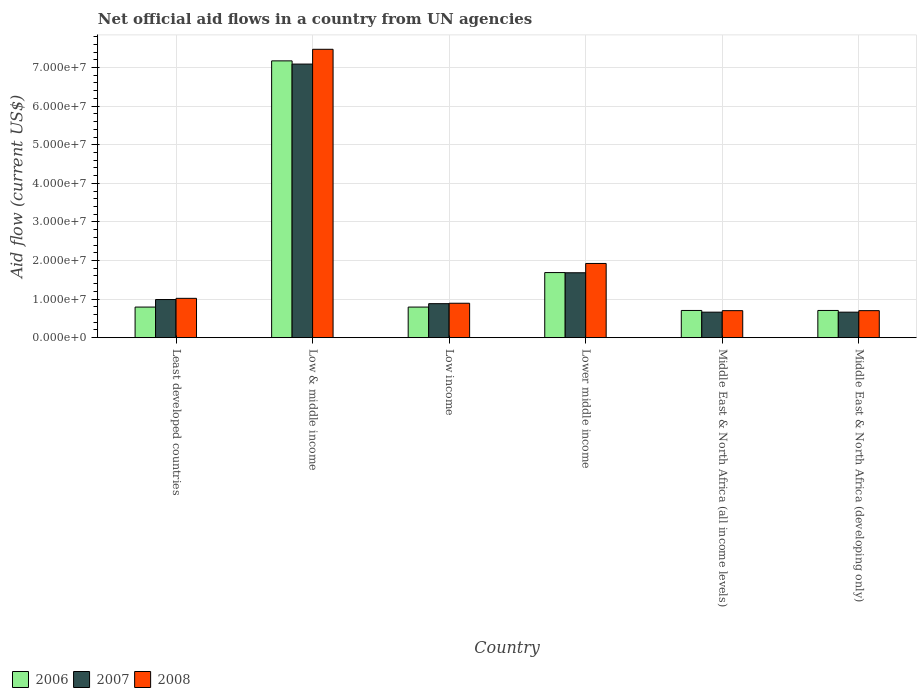Are the number of bars per tick equal to the number of legend labels?
Ensure brevity in your answer.  Yes. How many bars are there on the 6th tick from the right?
Your answer should be compact. 3. What is the label of the 5th group of bars from the left?
Your response must be concise. Middle East & North Africa (all income levels). What is the net official aid flow in 2006 in Low & middle income?
Ensure brevity in your answer.  7.17e+07. Across all countries, what is the maximum net official aid flow in 2008?
Your answer should be compact. 7.47e+07. Across all countries, what is the minimum net official aid flow in 2007?
Your answer should be compact. 6.61e+06. In which country was the net official aid flow in 2008 minimum?
Make the answer very short. Middle East & North Africa (all income levels). What is the total net official aid flow in 2008 in the graph?
Provide a succinct answer. 1.27e+08. What is the difference between the net official aid flow in 2007 in Low income and that in Middle East & North Africa (developing only)?
Provide a succinct answer. 2.20e+06. What is the difference between the net official aid flow in 2008 in Low income and the net official aid flow in 2006 in Low & middle income?
Your answer should be compact. -6.28e+07. What is the average net official aid flow in 2006 per country?
Your response must be concise. 1.98e+07. What is the difference between the net official aid flow of/in 2008 and net official aid flow of/in 2006 in Low income?
Offer a very short reply. 9.90e+05. In how many countries, is the net official aid flow in 2006 greater than 40000000 US$?
Give a very brief answer. 1. What is the ratio of the net official aid flow in 2007 in Low income to that in Middle East & North Africa (all income levels)?
Give a very brief answer. 1.33. Is the net official aid flow in 2006 in Least developed countries less than that in Middle East & North Africa (developing only)?
Provide a short and direct response. No. Is the difference between the net official aid flow in 2008 in Low & middle income and Lower middle income greater than the difference between the net official aid flow in 2006 in Low & middle income and Lower middle income?
Offer a very short reply. Yes. What is the difference between the highest and the second highest net official aid flow in 2008?
Your answer should be very brief. 5.55e+07. What is the difference between the highest and the lowest net official aid flow in 2008?
Ensure brevity in your answer.  6.77e+07. Is the sum of the net official aid flow in 2008 in Least developed countries and Middle East & North Africa (developing only) greater than the maximum net official aid flow in 2006 across all countries?
Ensure brevity in your answer.  No. How many countries are there in the graph?
Make the answer very short. 6. Does the graph contain any zero values?
Provide a short and direct response. No. Does the graph contain grids?
Your answer should be compact. Yes. Where does the legend appear in the graph?
Offer a very short reply. Bottom left. What is the title of the graph?
Provide a succinct answer. Net official aid flows in a country from UN agencies. What is the label or title of the X-axis?
Make the answer very short. Country. What is the Aid flow (current US$) in 2006 in Least developed countries?
Give a very brief answer. 7.93e+06. What is the Aid flow (current US$) of 2007 in Least developed countries?
Keep it short and to the point. 9.88e+06. What is the Aid flow (current US$) in 2008 in Least developed countries?
Ensure brevity in your answer.  1.02e+07. What is the Aid flow (current US$) in 2006 in Low & middle income?
Make the answer very short. 7.17e+07. What is the Aid flow (current US$) of 2007 in Low & middle income?
Your answer should be compact. 7.09e+07. What is the Aid flow (current US$) in 2008 in Low & middle income?
Your response must be concise. 7.47e+07. What is the Aid flow (current US$) of 2006 in Low income?
Offer a very short reply. 7.93e+06. What is the Aid flow (current US$) of 2007 in Low income?
Your response must be concise. 8.81e+06. What is the Aid flow (current US$) in 2008 in Low income?
Give a very brief answer. 8.92e+06. What is the Aid flow (current US$) in 2006 in Lower middle income?
Ensure brevity in your answer.  1.69e+07. What is the Aid flow (current US$) in 2007 in Lower middle income?
Your answer should be very brief. 1.68e+07. What is the Aid flow (current US$) of 2008 in Lower middle income?
Your response must be concise. 1.92e+07. What is the Aid flow (current US$) of 2006 in Middle East & North Africa (all income levels)?
Offer a very short reply. 7.05e+06. What is the Aid flow (current US$) in 2007 in Middle East & North Africa (all income levels)?
Ensure brevity in your answer.  6.61e+06. What is the Aid flow (current US$) of 2008 in Middle East & North Africa (all income levels)?
Give a very brief answer. 7.00e+06. What is the Aid flow (current US$) in 2006 in Middle East & North Africa (developing only)?
Make the answer very short. 7.05e+06. What is the Aid flow (current US$) of 2007 in Middle East & North Africa (developing only)?
Your answer should be very brief. 6.61e+06. What is the Aid flow (current US$) in 2008 in Middle East & North Africa (developing only)?
Ensure brevity in your answer.  7.00e+06. Across all countries, what is the maximum Aid flow (current US$) of 2006?
Make the answer very short. 7.17e+07. Across all countries, what is the maximum Aid flow (current US$) in 2007?
Your answer should be compact. 7.09e+07. Across all countries, what is the maximum Aid flow (current US$) in 2008?
Your response must be concise. 7.47e+07. Across all countries, what is the minimum Aid flow (current US$) of 2006?
Your answer should be compact. 7.05e+06. Across all countries, what is the minimum Aid flow (current US$) of 2007?
Make the answer very short. 6.61e+06. Across all countries, what is the minimum Aid flow (current US$) of 2008?
Your answer should be compact. 7.00e+06. What is the total Aid flow (current US$) of 2006 in the graph?
Ensure brevity in your answer.  1.19e+08. What is the total Aid flow (current US$) of 2007 in the graph?
Offer a terse response. 1.20e+08. What is the total Aid flow (current US$) in 2008 in the graph?
Offer a terse response. 1.27e+08. What is the difference between the Aid flow (current US$) of 2006 in Least developed countries and that in Low & middle income?
Offer a terse response. -6.38e+07. What is the difference between the Aid flow (current US$) of 2007 in Least developed countries and that in Low & middle income?
Provide a succinct answer. -6.10e+07. What is the difference between the Aid flow (current US$) of 2008 in Least developed countries and that in Low & middle income?
Keep it short and to the point. -6.45e+07. What is the difference between the Aid flow (current US$) in 2007 in Least developed countries and that in Low income?
Keep it short and to the point. 1.07e+06. What is the difference between the Aid flow (current US$) in 2008 in Least developed countries and that in Low income?
Your response must be concise. 1.27e+06. What is the difference between the Aid flow (current US$) in 2006 in Least developed countries and that in Lower middle income?
Keep it short and to the point. -8.94e+06. What is the difference between the Aid flow (current US$) of 2007 in Least developed countries and that in Lower middle income?
Offer a terse response. -6.94e+06. What is the difference between the Aid flow (current US$) in 2008 in Least developed countries and that in Lower middle income?
Your response must be concise. -9.04e+06. What is the difference between the Aid flow (current US$) in 2006 in Least developed countries and that in Middle East & North Africa (all income levels)?
Give a very brief answer. 8.80e+05. What is the difference between the Aid flow (current US$) of 2007 in Least developed countries and that in Middle East & North Africa (all income levels)?
Provide a short and direct response. 3.27e+06. What is the difference between the Aid flow (current US$) in 2008 in Least developed countries and that in Middle East & North Africa (all income levels)?
Keep it short and to the point. 3.19e+06. What is the difference between the Aid flow (current US$) in 2006 in Least developed countries and that in Middle East & North Africa (developing only)?
Offer a terse response. 8.80e+05. What is the difference between the Aid flow (current US$) of 2007 in Least developed countries and that in Middle East & North Africa (developing only)?
Your answer should be very brief. 3.27e+06. What is the difference between the Aid flow (current US$) in 2008 in Least developed countries and that in Middle East & North Africa (developing only)?
Provide a succinct answer. 3.19e+06. What is the difference between the Aid flow (current US$) in 2006 in Low & middle income and that in Low income?
Your answer should be very brief. 6.38e+07. What is the difference between the Aid flow (current US$) of 2007 in Low & middle income and that in Low income?
Give a very brief answer. 6.21e+07. What is the difference between the Aid flow (current US$) of 2008 in Low & middle income and that in Low income?
Keep it short and to the point. 6.58e+07. What is the difference between the Aid flow (current US$) in 2006 in Low & middle income and that in Lower middle income?
Provide a short and direct response. 5.49e+07. What is the difference between the Aid flow (current US$) in 2007 in Low & middle income and that in Lower middle income?
Make the answer very short. 5.41e+07. What is the difference between the Aid flow (current US$) in 2008 in Low & middle income and that in Lower middle income?
Make the answer very short. 5.55e+07. What is the difference between the Aid flow (current US$) of 2006 in Low & middle income and that in Middle East & North Africa (all income levels)?
Provide a succinct answer. 6.47e+07. What is the difference between the Aid flow (current US$) of 2007 in Low & middle income and that in Middle East & North Africa (all income levels)?
Make the answer very short. 6.43e+07. What is the difference between the Aid flow (current US$) in 2008 in Low & middle income and that in Middle East & North Africa (all income levels)?
Your response must be concise. 6.77e+07. What is the difference between the Aid flow (current US$) in 2006 in Low & middle income and that in Middle East & North Africa (developing only)?
Your response must be concise. 6.47e+07. What is the difference between the Aid flow (current US$) in 2007 in Low & middle income and that in Middle East & North Africa (developing only)?
Offer a terse response. 6.43e+07. What is the difference between the Aid flow (current US$) of 2008 in Low & middle income and that in Middle East & North Africa (developing only)?
Your response must be concise. 6.77e+07. What is the difference between the Aid flow (current US$) in 2006 in Low income and that in Lower middle income?
Your answer should be compact. -8.94e+06. What is the difference between the Aid flow (current US$) of 2007 in Low income and that in Lower middle income?
Offer a terse response. -8.01e+06. What is the difference between the Aid flow (current US$) of 2008 in Low income and that in Lower middle income?
Your response must be concise. -1.03e+07. What is the difference between the Aid flow (current US$) of 2006 in Low income and that in Middle East & North Africa (all income levels)?
Keep it short and to the point. 8.80e+05. What is the difference between the Aid flow (current US$) of 2007 in Low income and that in Middle East & North Africa (all income levels)?
Make the answer very short. 2.20e+06. What is the difference between the Aid flow (current US$) in 2008 in Low income and that in Middle East & North Africa (all income levels)?
Offer a terse response. 1.92e+06. What is the difference between the Aid flow (current US$) of 2006 in Low income and that in Middle East & North Africa (developing only)?
Give a very brief answer. 8.80e+05. What is the difference between the Aid flow (current US$) of 2007 in Low income and that in Middle East & North Africa (developing only)?
Provide a succinct answer. 2.20e+06. What is the difference between the Aid flow (current US$) of 2008 in Low income and that in Middle East & North Africa (developing only)?
Keep it short and to the point. 1.92e+06. What is the difference between the Aid flow (current US$) in 2006 in Lower middle income and that in Middle East & North Africa (all income levels)?
Your answer should be compact. 9.82e+06. What is the difference between the Aid flow (current US$) of 2007 in Lower middle income and that in Middle East & North Africa (all income levels)?
Make the answer very short. 1.02e+07. What is the difference between the Aid flow (current US$) of 2008 in Lower middle income and that in Middle East & North Africa (all income levels)?
Ensure brevity in your answer.  1.22e+07. What is the difference between the Aid flow (current US$) of 2006 in Lower middle income and that in Middle East & North Africa (developing only)?
Keep it short and to the point. 9.82e+06. What is the difference between the Aid flow (current US$) of 2007 in Lower middle income and that in Middle East & North Africa (developing only)?
Your answer should be compact. 1.02e+07. What is the difference between the Aid flow (current US$) of 2008 in Lower middle income and that in Middle East & North Africa (developing only)?
Your answer should be very brief. 1.22e+07. What is the difference between the Aid flow (current US$) in 2006 in Middle East & North Africa (all income levels) and that in Middle East & North Africa (developing only)?
Your answer should be very brief. 0. What is the difference between the Aid flow (current US$) in 2007 in Middle East & North Africa (all income levels) and that in Middle East & North Africa (developing only)?
Your answer should be compact. 0. What is the difference between the Aid flow (current US$) in 2006 in Least developed countries and the Aid flow (current US$) in 2007 in Low & middle income?
Offer a terse response. -6.30e+07. What is the difference between the Aid flow (current US$) in 2006 in Least developed countries and the Aid flow (current US$) in 2008 in Low & middle income?
Your answer should be very brief. -6.68e+07. What is the difference between the Aid flow (current US$) of 2007 in Least developed countries and the Aid flow (current US$) of 2008 in Low & middle income?
Offer a very short reply. -6.48e+07. What is the difference between the Aid flow (current US$) in 2006 in Least developed countries and the Aid flow (current US$) in 2007 in Low income?
Keep it short and to the point. -8.80e+05. What is the difference between the Aid flow (current US$) of 2006 in Least developed countries and the Aid flow (current US$) of 2008 in Low income?
Your answer should be compact. -9.90e+05. What is the difference between the Aid flow (current US$) of 2007 in Least developed countries and the Aid flow (current US$) of 2008 in Low income?
Your answer should be very brief. 9.60e+05. What is the difference between the Aid flow (current US$) of 2006 in Least developed countries and the Aid flow (current US$) of 2007 in Lower middle income?
Your response must be concise. -8.89e+06. What is the difference between the Aid flow (current US$) in 2006 in Least developed countries and the Aid flow (current US$) in 2008 in Lower middle income?
Make the answer very short. -1.13e+07. What is the difference between the Aid flow (current US$) in 2007 in Least developed countries and the Aid flow (current US$) in 2008 in Lower middle income?
Keep it short and to the point. -9.35e+06. What is the difference between the Aid flow (current US$) in 2006 in Least developed countries and the Aid flow (current US$) in 2007 in Middle East & North Africa (all income levels)?
Provide a short and direct response. 1.32e+06. What is the difference between the Aid flow (current US$) in 2006 in Least developed countries and the Aid flow (current US$) in 2008 in Middle East & North Africa (all income levels)?
Make the answer very short. 9.30e+05. What is the difference between the Aid flow (current US$) of 2007 in Least developed countries and the Aid flow (current US$) of 2008 in Middle East & North Africa (all income levels)?
Your response must be concise. 2.88e+06. What is the difference between the Aid flow (current US$) of 2006 in Least developed countries and the Aid flow (current US$) of 2007 in Middle East & North Africa (developing only)?
Ensure brevity in your answer.  1.32e+06. What is the difference between the Aid flow (current US$) in 2006 in Least developed countries and the Aid flow (current US$) in 2008 in Middle East & North Africa (developing only)?
Provide a short and direct response. 9.30e+05. What is the difference between the Aid flow (current US$) of 2007 in Least developed countries and the Aid flow (current US$) of 2008 in Middle East & North Africa (developing only)?
Offer a very short reply. 2.88e+06. What is the difference between the Aid flow (current US$) in 2006 in Low & middle income and the Aid flow (current US$) in 2007 in Low income?
Make the answer very short. 6.29e+07. What is the difference between the Aid flow (current US$) in 2006 in Low & middle income and the Aid flow (current US$) in 2008 in Low income?
Make the answer very short. 6.28e+07. What is the difference between the Aid flow (current US$) of 2007 in Low & middle income and the Aid flow (current US$) of 2008 in Low income?
Ensure brevity in your answer.  6.20e+07. What is the difference between the Aid flow (current US$) in 2006 in Low & middle income and the Aid flow (current US$) in 2007 in Lower middle income?
Provide a succinct answer. 5.49e+07. What is the difference between the Aid flow (current US$) in 2006 in Low & middle income and the Aid flow (current US$) in 2008 in Lower middle income?
Offer a terse response. 5.25e+07. What is the difference between the Aid flow (current US$) in 2007 in Low & middle income and the Aid flow (current US$) in 2008 in Lower middle income?
Ensure brevity in your answer.  5.17e+07. What is the difference between the Aid flow (current US$) of 2006 in Low & middle income and the Aid flow (current US$) of 2007 in Middle East & North Africa (all income levels)?
Provide a succinct answer. 6.51e+07. What is the difference between the Aid flow (current US$) in 2006 in Low & middle income and the Aid flow (current US$) in 2008 in Middle East & North Africa (all income levels)?
Offer a very short reply. 6.47e+07. What is the difference between the Aid flow (current US$) in 2007 in Low & middle income and the Aid flow (current US$) in 2008 in Middle East & North Africa (all income levels)?
Keep it short and to the point. 6.39e+07. What is the difference between the Aid flow (current US$) in 2006 in Low & middle income and the Aid flow (current US$) in 2007 in Middle East & North Africa (developing only)?
Your answer should be compact. 6.51e+07. What is the difference between the Aid flow (current US$) of 2006 in Low & middle income and the Aid flow (current US$) of 2008 in Middle East & North Africa (developing only)?
Make the answer very short. 6.47e+07. What is the difference between the Aid flow (current US$) in 2007 in Low & middle income and the Aid flow (current US$) in 2008 in Middle East & North Africa (developing only)?
Your response must be concise. 6.39e+07. What is the difference between the Aid flow (current US$) in 2006 in Low income and the Aid flow (current US$) in 2007 in Lower middle income?
Provide a short and direct response. -8.89e+06. What is the difference between the Aid flow (current US$) of 2006 in Low income and the Aid flow (current US$) of 2008 in Lower middle income?
Your answer should be compact. -1.13e+07. What is the difference between the Aid flow (current US$) of 2007 in Low income and the Aid flow (current US$) of 2008 in Lower middle income?
Your answer should be very brief. -1.04e+07. What is the difference between the Aid flow (current US$) of 2006 in Low income and the Aid flow (current US$) of 2007 in Middle East & North Africa (all income levels)?
Your answer should be very brief. 1.32e+06. What is the difference between the Aid flow (current US$) of 2006 in Low income and the Aid flow (current US$) of 2008 in Middle East & North Africa (all income levels)?
Offer a very short reply. 9.30e+05. What is the difference between the Aid flow (current US$) of 2007 in Low income and the Aid flow (current US$) of 2008 in Middle East & North Africa (all income levels)?
Offer a very short reply. 1.81e+06. What is the difference between the Aid flow (current US$) of 2006 in Low income and the Aid flow (current US$) of 2007 in Middle East & North Africa (developing only)?
Give a very brief answer. 1.32e+06. What is the difference between the Aid flow (current US$) of 2006 in Low income and the Aid flow (current US$) of 2008 in Middle East & North Africa (developing only)?
Provide a short and direct response. 9.30e+05. What is the difference between the Aid flow (current US$) of 2007 in Low income and the Aid flow (current US$) of 2008 in Middle East & North Africa (developing only)?
Provide a succinct answer. 1.81e+06. What is the difference between the Aid flow (current US$) of 2006 in Lower middle income and the Aid flow (current US$) of 2007 in Middle East & North Africa (all income levels)?
Keep it short and to the point. 1.03e+07. What is the difference between the Aid flow (current US$) of 2006 in Lower middle income and the Aid flow (current US$) of 2008 in Middle East & North Africa (all income levels)?
Your answer should be very brief. 9.87e+06. What is the difference between the Aid flow (current US$) of 2007 in Lower middle income and the Aid flow (current US$) of 2008 in Middle East & North Africa (all income levels)?
Provide a short and direct response. 9.82e+06. What is the difference between the Aid flow (current US$) in 2006 in Lower middle income and the Aid flow (current US$) in 2007 in Middle East & North Africa (developing only)?
Give a very brief answer. 1.03e+07. What is the difference between the Aid flow (current US$) of 2006 in Lower middle income and the Aid flow (current US$) of 2008 in Middle East & North Africa (developing only)?
Offer a terse response. 9.87e+06. What is the difference between the Aid flow (current US$) in 2007 in Lower middle income and the Aid flow (current US$) in 2008 in Middle East & North Africa (developing only)?
Your response must be concise. 9.82e+06. What is the difference between the Aid flow (current US$) of 2006 in Middle East & North Africa (all income levels) and the Aid flow (current US$) of 2007 in Middle East & North Africa (developing only)?
Offer a terse response. 4.40e+05. What is the difference between the Aid flow (current US$) of 2007 in Middle East & North Africa (all income levels) and the Aid flow (current US$) of 2008 in Middle East & North Africa (developing only)?
Offer a terse response. -3.90e+05. What is the average Aid flow (current US$) in 2006 per country?
Provide a succinct answer. 1.98e+07. What is the average Aid flow (current US$) of 2007 per country?
Offer a terse response. 1.99e+07. What is the average Aid flow (current US$) in 2008 per country?
Provide a short and direct response. 2.12e+07. What is the difference between the Aid flow (current US$) in 2006 and Aid flow (current US$) in 2007 in Least developed countries?
Make the answer very short. -1.95e+06. What is the difference between the Aid flow (current US$) in 2006 and Aid flow (current US$) in 2008 in Least developed countries?
Your answer should be compact. -2.26e+06. What is the difference between the Aid flow (current US$) of 2007 and Aid flow (current US$) of 2008 in Least developed countries?
Provide a short and direct response. -3.10e+05. What is the difference between the Aid flow (current US$) in 2006 and Aid flow (current US$) in 2007 in Low & middle income?
Ensure brevity in your answer.  8.30e+05. What is the difference between the Aid flow (current US$) of 2006 and Aid flow (current US$) of 2008 in Low & middle income?
Provide a succinct answer. -3.00e+06. What is the difference between the Aid flow (current US$) in 2007 and Aid flow (current US$) in 2008 in Low & middle income?
Make the answer very short. -3.83e+06. What is the difference between the Aid flow (current US$) in 2006 and Aid flow (current US$) in 2007 in Low income?
Keep it short and to the point. -8.80e+05. What is the difference between the Aid flow (current US$) of 2006 and Aid flow (current US$) of 2008 in Low income?
Offer a terse response. -9.90e+05. What is the difference between the Aid flow (current US$) in 2006 and Aid flow (current US$) in 2008 in Lower middle income?
Provide a short and direct response. -2.36e+06. What is the difference between the Aid flow (current US$) of 2007 and Aid flow (current US$) of 2008 in Lower middle income?
Offer a very short reply. -2.41e+06. What is the difference between the Aid flow (current US$) in 2006 and Aid flow (current US$) in 2007 in Middle East & North Africa (all income levels)?
Provide a short and direct response. 4.40e+05. What is the difference between the Aid flow (current US$) of 2007 and Aid flow (current US$) of 2008 in Middle East & North Africa (all income levels)?
Keep it short and to the point. -3.90e+05. What is the difference between the Aid flow (current US$) in 2006 and Aid flow (current US$) in 2008 in Middle East & North Africa (developing only)?
Your answer should be very brief. 5.00e+04. What is the difference between the Aid flow (current US$) of 2007 and Aid flow (current US$) of 2008 in Middle East & North Africa (developing only)?
Give a very brief answer. -3.90e+05. What is the ratio of the Aid flow (current US$) in 2006 in Least developed countries to that in Low & middle income?
Your response must be concise. 0.11. What is the ratio of the Aid flow (current US$) of 2007 in Least developed countries to that in Low & middle income?
Make the answer very short. 0.14. What is the ratio of the Aid flow (current US$) of 2008 in Least developed countries to that in Low & middle income?
Offer a very short reply. 0.14. What is the ratio of the Aid flow (current US$) in 2007 in Least developed countries to that in Low income?
Keep it short and to the point. 1.12. What is the ratio of the Aid flow (current US$) in 2008 in Least developed countries to that in Low income?
Your response must be concise. 1.14. What is the ratio of the Aid flow (current US$) of 2006 in Least developed countries to that in Lower middle income?
Make the answer very short. 0.47. What is the ratio of the Aid flow (current US$) in 2007 in Least developed countries to that in Lower middle income?
Keep it short and to the point. 0.59. What is the ratio of the Aid flow (current US$) in 2008 in Least developed countries to that in Lower middle income?
Keep it short and to the point. 0.53. What is the ratio of the Aid flow (current US$) of 2006 in Least developed countries to that in Middle East & North Africa (all income levels)?
Offer a very short reply. 1.12. What is the ratio of the Aid flow (current US$) of 2007 in Least developed countries to that in Middle East & North Africa (all income levels)?
Keep it short and to the point. 1.49. What is the ratio of the Aid flow (current US$) of 2008 in Least developed countries to that in Middle East & North Africa (all income levels)?
Your answer should be very brief. 1.46. What is the ratio of the Aid flow (current US$) in 2006 in Least developed countries to that in Middle East & North Africa (developing only)?
Your response must be concise. 1.12. What is the ratio of the Aid flow (current US$) of 2007 in Least developed countries to that in Middle East & North Africa (developing only)?
Keep it short and to the point. 1.49. What is the ratio of the Aid flow (current US$) in 2008 in Least developed countries to that in Middle East & North Africa (developing only)?
Offer a terse response. 1.46. What is the ratio of the Aid flow (current US$) of 2006 in Low & middle income to that in Low income?
Your response must be concise. 9.05. What is the ratio of the Aid flow (current US$) of 2007 in Low & middle income to that in Low income?
Give a very brief answer. 8.05. What is the ratio of the Aid flow (current US$) in 2008 in Low & middle income to that in Low income?
Make the answer very short. 8.38. What is the ratio of the Aid flow (current US$) in 2006 in Low & middle income to that in Lower middle income?
Offer a terse response. 4.25. What is the ratio of the Aid flow (current US$) of 2007 in Low & middle income to that in Lower middle income?
Provide a succinct answer. 4.22. What is the ratio of the Aid flow (current US$) of 2008 in Low & middle income to that in Lower middle income?
Your response must be concise. 3.89. What is the ratio of the Aid flow (current US$) of 2006 in Low & middle income to that in Middle East & North Africa (all income levels)?
Keep it short and to the point. 10.17. What is the ratio of the Aid flow (current US$) in 2007 in Low & middle income to that in Middle East & North Africa (all income levels)?
Your answer should be very brief. 10.73. What is the ratio of the Aid flow (current US$) in 2008 in Low & middle income to that in Middle East & North Africa (all income levels)?
Provide a short and direct response. 10.68. What is the ratio of the Aid flow (current US$) of 2006 in Low & middle income to that in Middle East & North Africa (developing only)?
Keep it short and to the point. 10.17. What is the ratio of the Aid flow (current US$) of 2007 in Low & middle income to that in Middle East & North Africa (developing only)?
Your answer should be very brief. 10.73. What is the ratio of the Aid flow (current US$) in 2008 in Low & middle income to that in Middle East & North Africa (developing only)?
Keep it short and to the point. 10.68. What is the ratio of the Aid flow (current US$) of 2006 in Low income to that in Lower middle income?
Ensure brevity in your answer.  0.47. What is the ratio of the Aid flow (current US$) of 2007 in Low income to that in Lower middle income?
Provide a succinct answer. 0.52. What is the ratio of the Aid flow (current US$) of 2008 in Low income to that in Lower middle income?
Offer a terse response. 0.46. What is the ratio of the Aid flow (current US$) in 2006 in Low income to that in Middle East & North Africa (all income levels)?
Make the answer very short. 1.12. What is the ratio of the Aid flow (current US$) in 2007 in Low income to that in Middle East & North Africa (all income levels)?
Your answer should be compact. 1.33. What is the ratio of the Aid flow (current US$) in 2008 in Low income to that in Middle East & North Africa (all income levels)?
Give a very brief answer. 1.27. What is the ratio of the Aid flow (current US$) in 2006 in Low income to that in Middle East & North Africa (developing only)?
Offer a terse response. 1.12. What is the ratio of the Aid flow (current US$) of 2007 in Low income to that in Middle East & North Africa (developing only)?
Provide a short and direct response. 1.33. What is the ratio of the Aid flow (current US$) in 2008 in Low income to that in Middle East & North Africa (developing only)?
Your answer should be very brief. 1.27. What is the ratio of the Aid flow (current US$) of 2006 in Lower middle income to that in Middle East & North Africa (all income levels)?
Keep it short and to the point. 2.39. What is the ratio of the Aid flow (current US$) in 2007 in Lower middle income to that in Middle East & North Africa (all income levels)?
Provide a succinct answer. 2.54. What is the ratio of the Aid flow (current US$) of 2008 in Lower middle income to that in Middle East & North Africa (all income levels)?
Provide a short and direct response. 2.75. What is the ratio of the Aid flow (current US$) in 2006 in Lower middle income to that in Middle East & North Africa (developing only)?
Provide a short and direct response. 2.39. What is the ratio of the Aid flow (current US$) of 2007 in Lower middle income to that in Middle East & North Africa (developing only)?
Your response must be concise. 2.54. What is the ratio of the Aid flow (current US$) of 2008 in Lower middle income to that in Middle East & North Africa (developing only)?
Ensure brevity in your answer.  2.75. What is the ratio of the Aid flow (current US$) in 2006 in Middle East & North Africa (all income levels) to that in Middle East & North Africa (developing only)?
Give a very brief answer. 1. What is the ratio of the Aid flow (current US$) of 2008 in Middle East & North Africa (all income levels) to that in Middle East & North Africa (developing only)?
Ensure brevity in your answer.  1. What is the difference between the highest and the second highest Aid flow (current US$) in 2006?
Your answer should be compact. 5.49e+07. What is the difference between the highest and the second highest Aid flow (current US$) in 2007?
Offer a very short reply. 5.41e+07. What is the difference between the highest and the second highest Aid flow (current US$) in 2008?
Provide a short and direct response. 5.55e+07. What is the difference between the highest and the lowest Aid flow (current US$) of 2006?
Your answer should be compact. 6.47e+07. What is the difference between the highest and the lowest Aid flow (current US$) of 2007?
Your answer should be very brief. 6.43e+07. What is the difference between the highest and the lowest Aid flow (current US$) of 2008?
Give a very brief answer. 6.77e+07. 